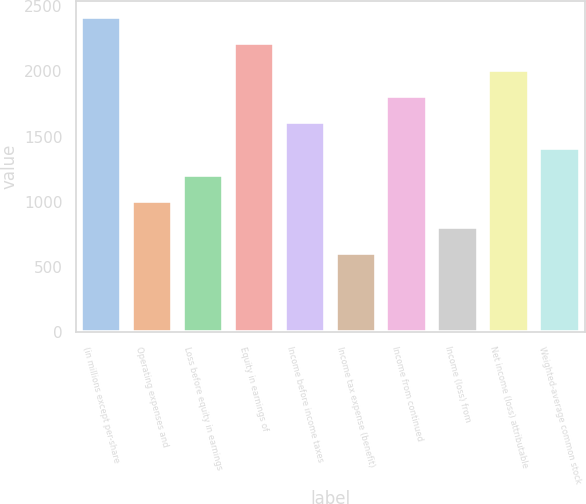<chart> <loc_0><loc_0><loc_500><loc_500><bar_chart><fcel>(in millions except per-share<fcel>Operating expenses and<fcel>Loss before equity in earnings<fcel>Equity in earnings of<fcel>Income before income taxes<fcel>Income tax expense (benefit)<fcel>Income from continued<fcel>Income (loss) from<fcel>Net income (loss) attributable<fcel>Weighted-average common stock<nl><fcel>2415.59<fcel>1006.56<fcel>1207.85<fcel>2214.3<fcel>1610.43<fcel>603.98<fcel>1811.72<fcel>805.27<fcel>2013.01<fcel>1409.14<nl></chart> 